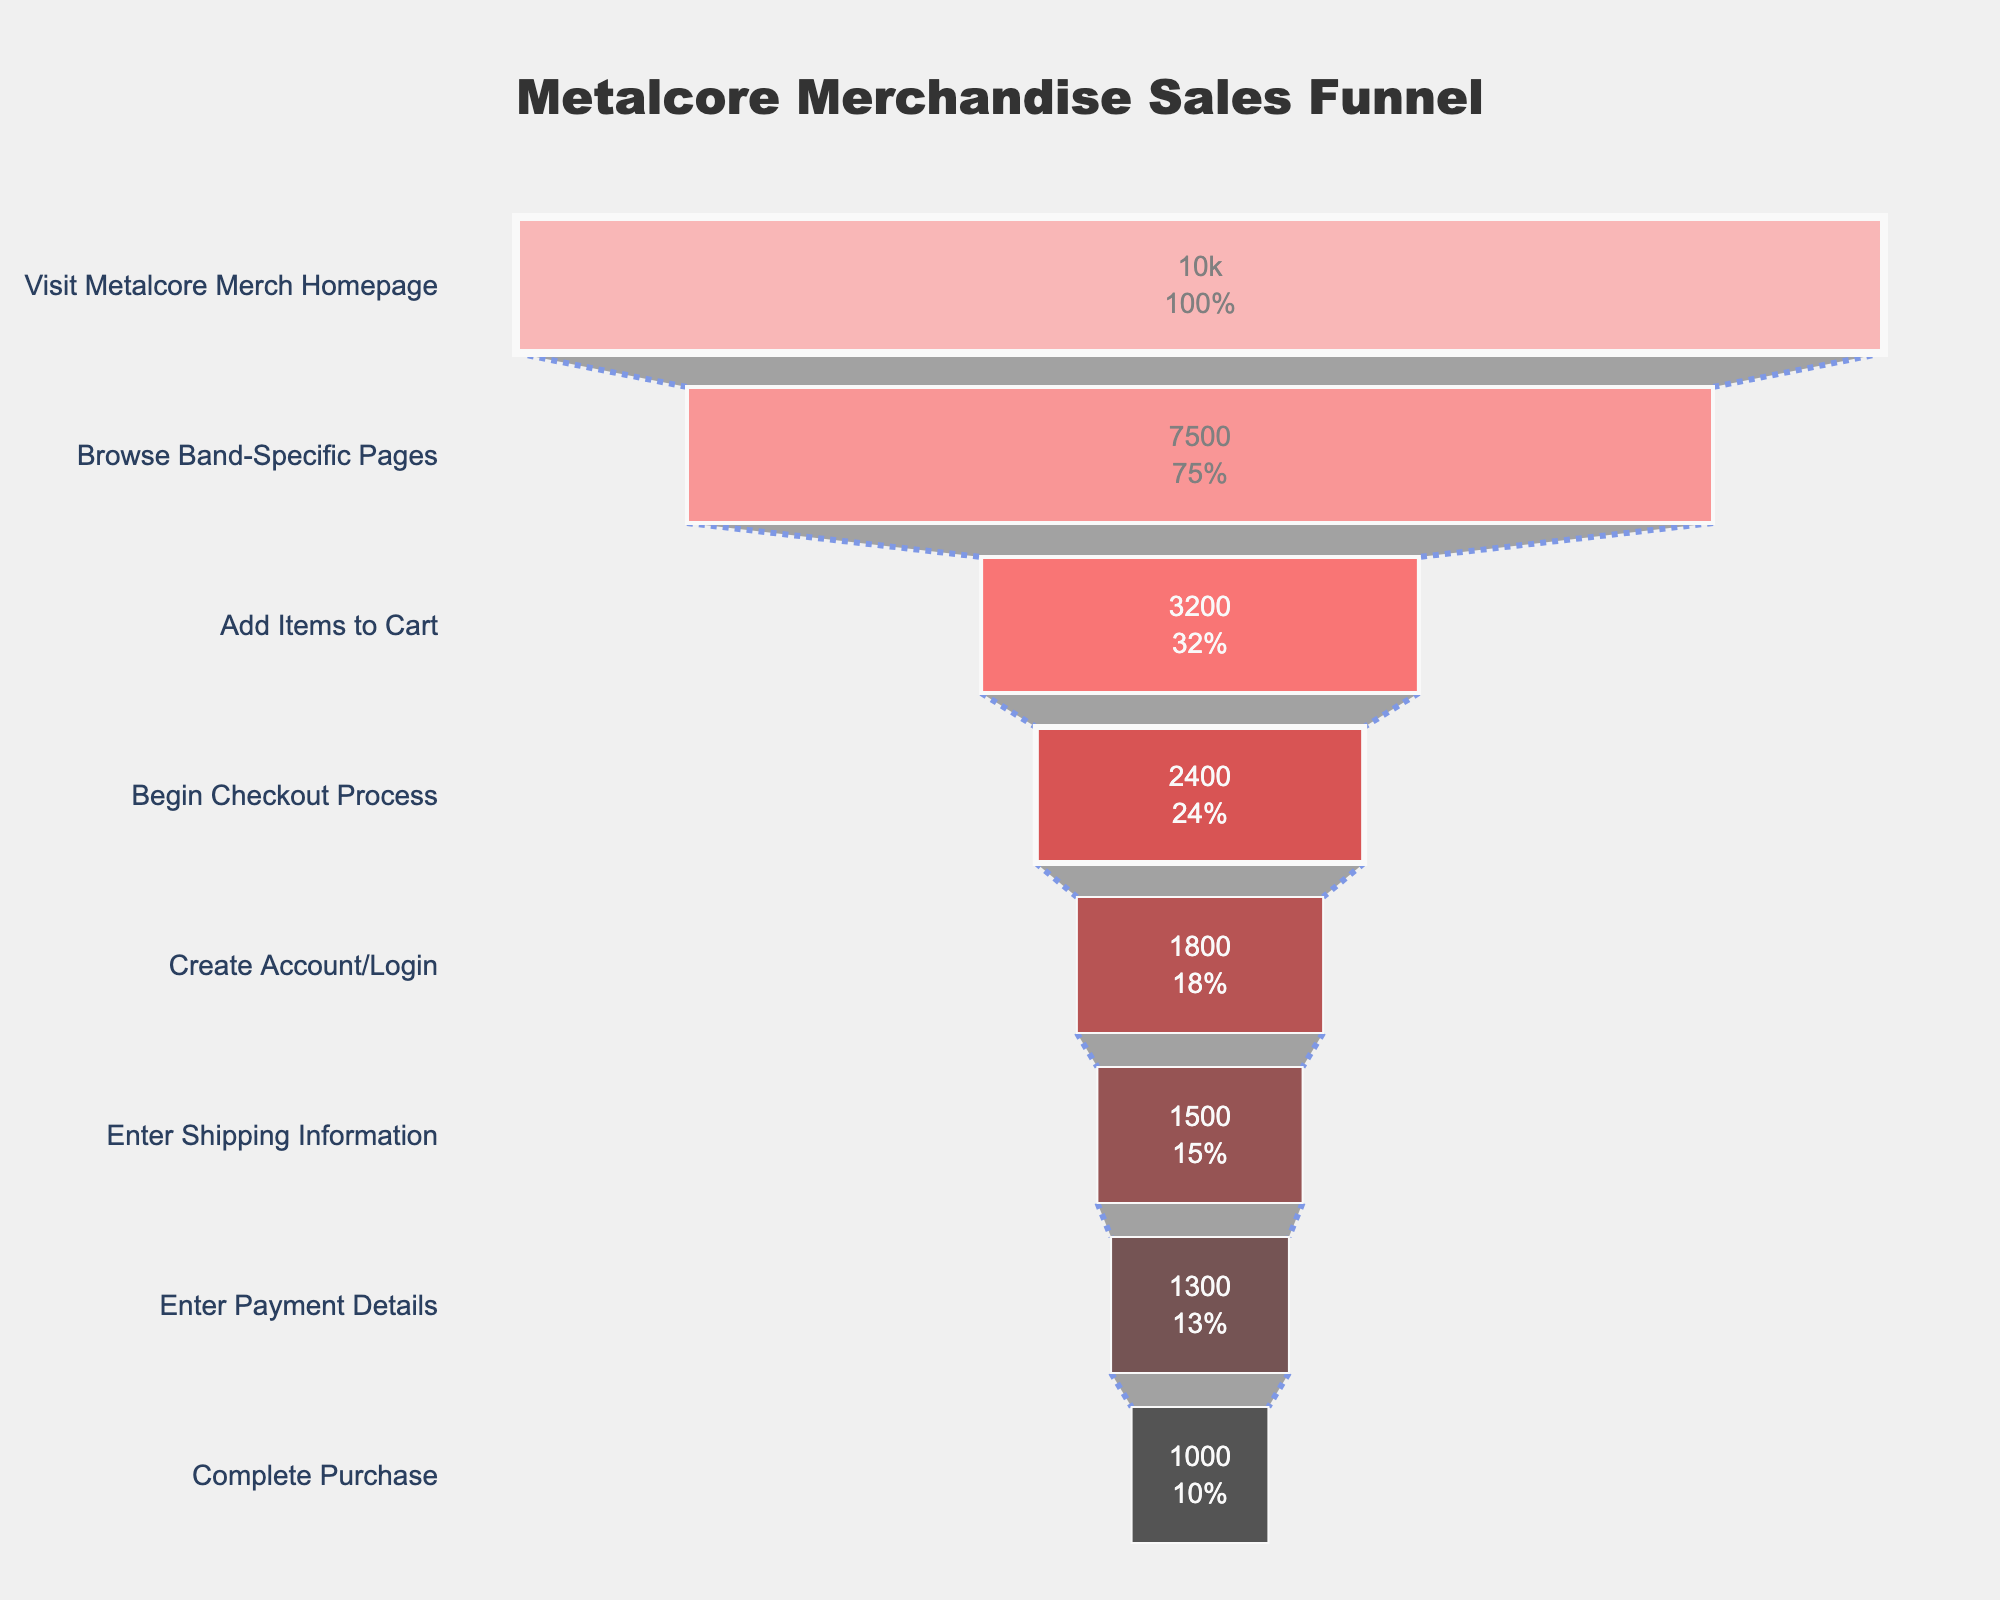What is the title of the funnel chart? The title is located at the top center of the chart. By reading this text, we can determine the title.
Answer: Metalcore Merchandise Sales Funnel Which stage has the highest number of users? The number of users decreases at each stage of the funnel. The first stage starts with the highest number.
Answer: Visit Metalcore Merch Homepage How many users completed the purchase? The number of users who completed the purchase is given in the last stage of the funnel.
Answer: 1000 What percentage of users who visit the homepage end up completing a purchase? To find the percentage, use the formula: (number of users who complete purchase / number of users who visit homepage) * 100. (1000 / 10000) * 100 = 10%
Answer: 10% What is the difference in user count between the 'Add Items to Cart' stage and the 'Begin Checkout Process' stage? To find this, subtract the number of users in the 'Begin Checkout Process' stage from those in the 'Add Items to Cart' stage. 3200 - 2400 = 800
Answer: 800 Which stage shows a significant drop in users compared to the previous stage? Look at the user counts between each consecutive stage and identify the one with the largest drop. The drop from 'Browse Band-Specific Pages' to 'Add Items to Cart' is the most significant (7500 to 3200).
Answer: Add Items to Cart What percentage of users who began the checkout process completed the purchase? To calculate the percentage, use the formula: (number of users who complete purchase / number of users who begin checkout process) * 100. (1000 / 2400) * 100 = 41.67%
Answer: 41.67% How many users dropped off during the 'Enter Payment Details' stage? Subtract the number of users in the 'Complete Purchase' stage from those in the 'Enter Payment Details' stage. 1300 - 1000 = 300
Answer: 300 Which stage has the lowest user count and what is that count? The stage with the smallest user count is the last stage of the funnel, which has the lowest value.
Answer: Complete Purchase, 1000 What is the average number of users across all stages? Sum all the user counts and divide by the number of stages. (10000 + 7500 + 3200 + 2400 + 1800 + 1500 + 1300 + 1000) / 8 = 4125
Answer: 4125 